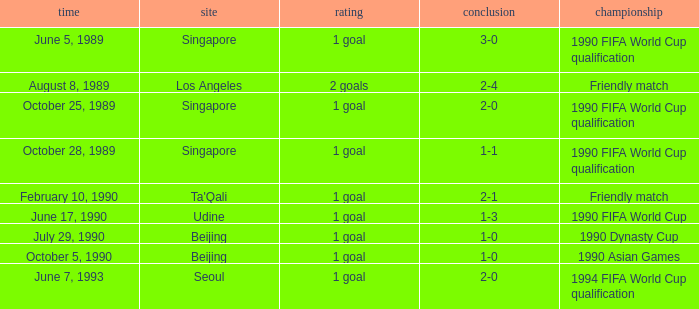What is the score of the match on October 5, 1990? 1 goal. 